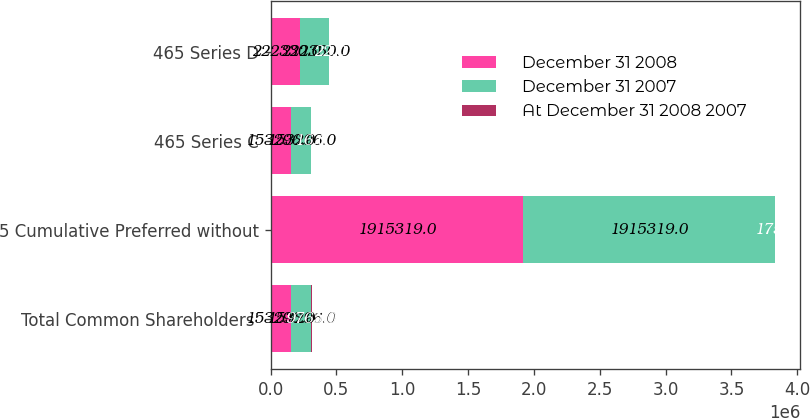Convert chart to OTSL. <chart><loc_0><loc_0><loc_500><loc_500><stacked_bar_chart><ecel><fcel>Total Common Shareholders'<fcel>5 Cumulative Preferred without<fcel>465 Series C<fcel>465 Series D<nl><fcel>December 31 2008<fcel>153296<fcel>1.91532e+06<fcel>153296<fcel>222330<nl><fcel>December 31 2007<fcel>153296<fcel>1.91532e+06<fcel>153296<fcel>222330<nl><fcel>At December 31 2008 2007<fcel>9765<fcel>175<fcel>16<fcel>22<nl></chart> 